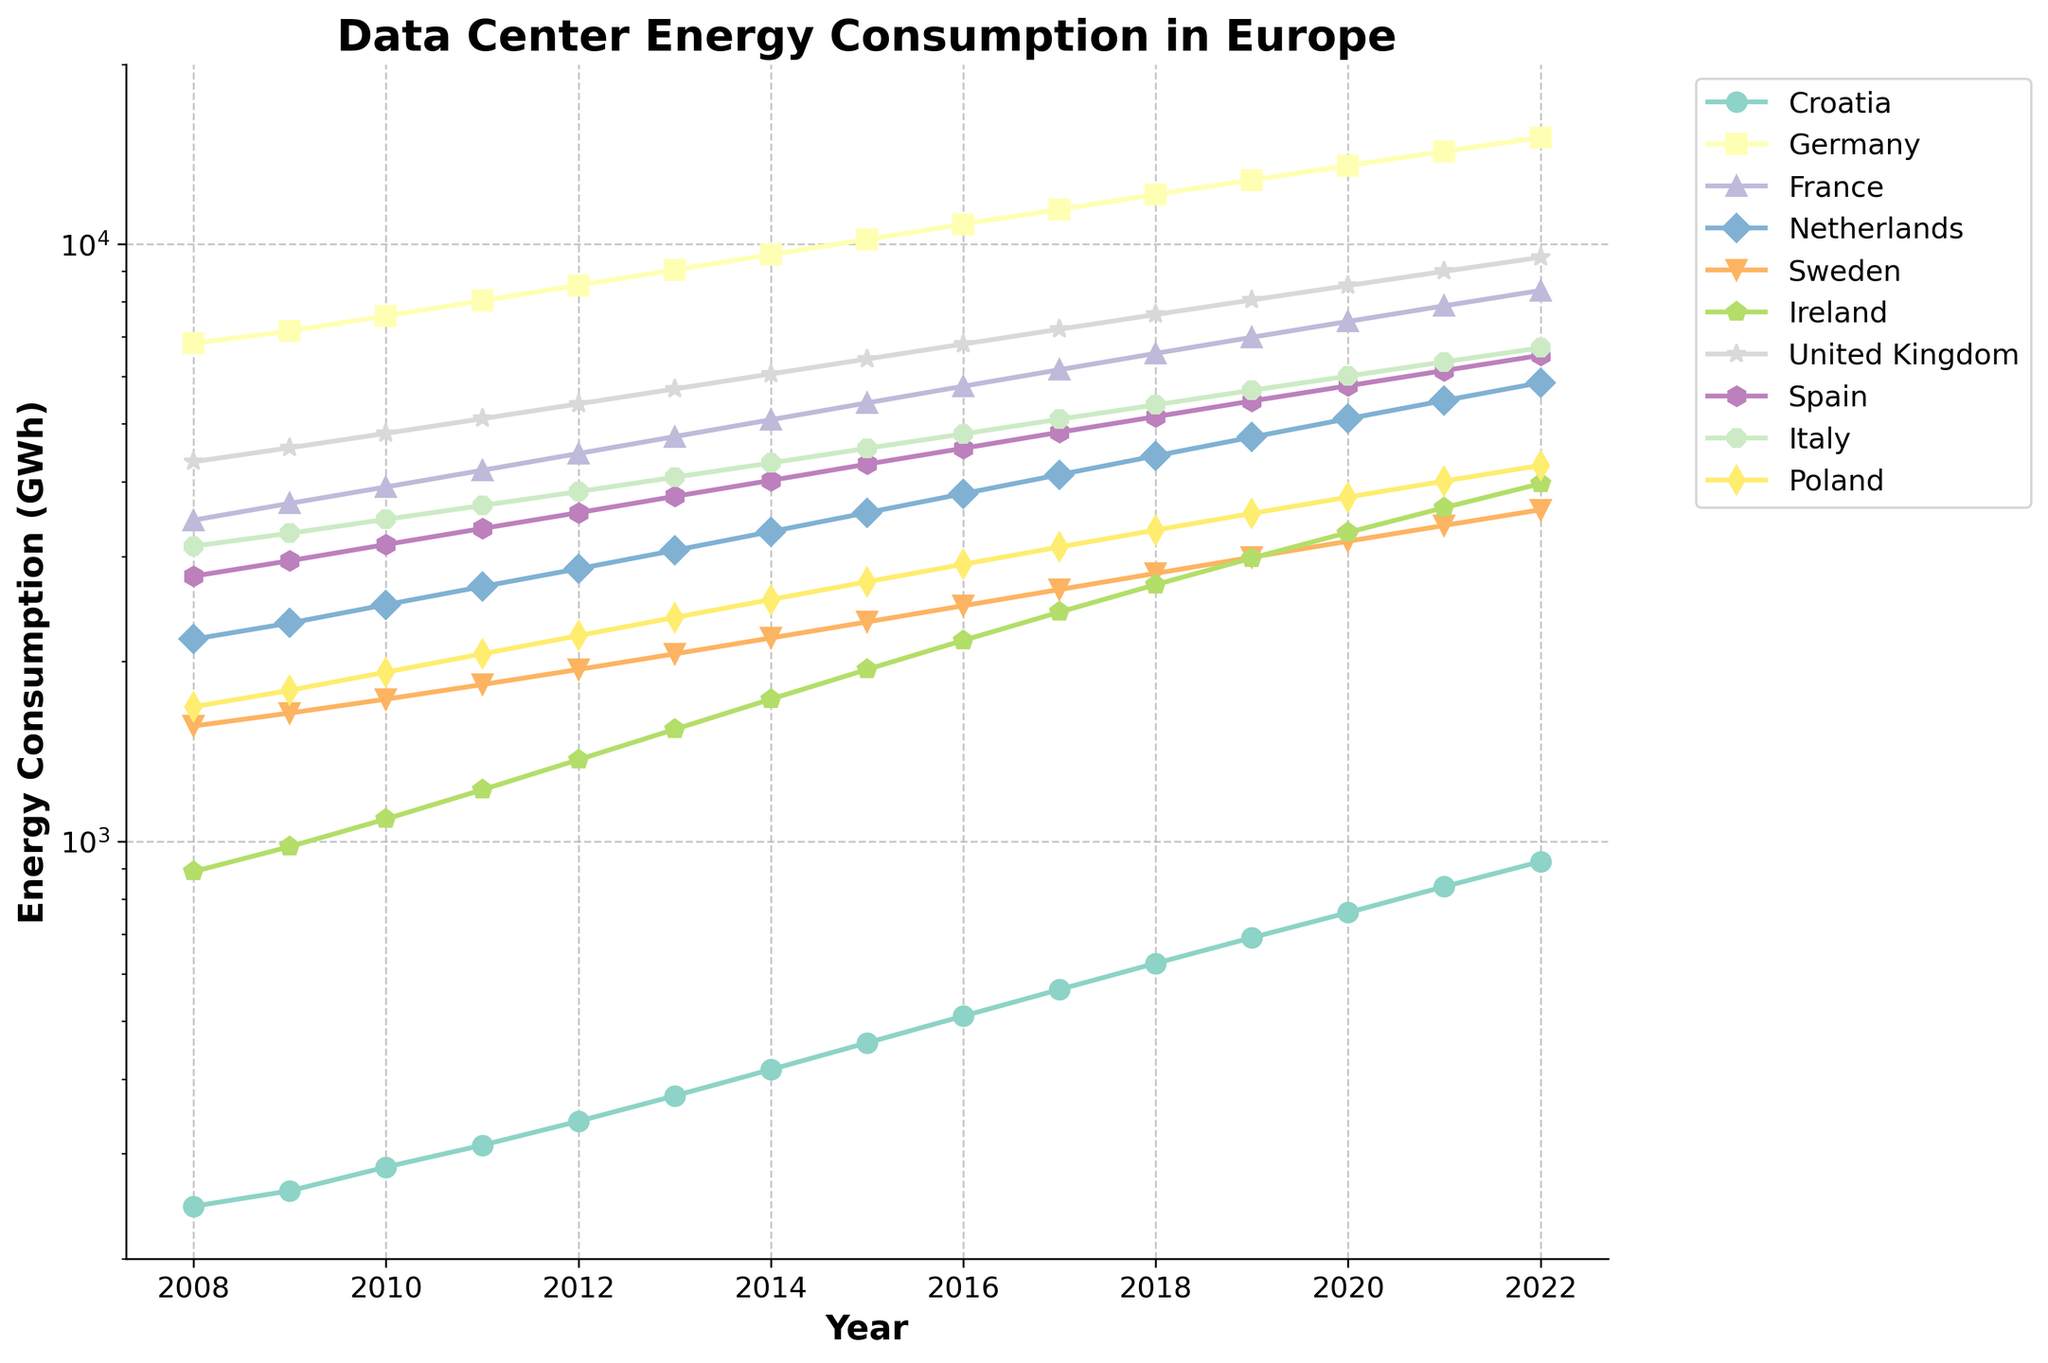What was the energy consumption in Germany in the year 2012 compared to that in Ireland? In the year 2012, Germany's energy consumption is shown in one curve, and Ireland's in another. Check the value for each country and compare them. Germany consumed 8530 GWh, while Ireland consumed 1370 GWh. Therefore, Germany's consumption was higher.
Answer: Germany's consumption was higher Which country had the lowest energy consumption in 2008, and by how much? Look at the values for all countries in 2008. The lowest value is for Croatia with 245 GWh. Other countries have values higher than that.
Answer: Croatia, 245 GWh What's the average increase in energy consumption for Sweden from 2008 to 2022? To find the increase for each year and then average them: first determine the consumption for 2008 (1560 GWh) and for 2022 (3590 GWh). The total increase is 3590 - 1560 = 2030 GWh. There are 14 intervals between 15 years, so the average increase is 2030 / 14.
Answer: 145 GWh per year By how much did the energy consumption in the Netherlands increase from 2010 to 2020? Find the value of Netherlands' consumption in 2010 (2490 GWh) and 2020 (5100 GWh). Subtract the value of 2010 from the value of 2020 (5100 - 2490).
Answer: 2610 GWh Which country's energy consumption curve shows the steepest increase around the 2015 mark? Look for the curve that shows a noticeable steep increase around 2015. Ireland's curve from 2015 to 2016 has a visible steep slope.
Answer: Ireland Compare the energy consumption growth rate of Italy and Spain from 2018 to 2021. Which country has a higher growth rate? Calculate the difference in energy consumption for Italy (6350 - 5380) and Spain (6140 - 5140) from 2018 to 2021. The growth rate for Italy is 6350 - 5380 = 970 GWh, and for Spain is 6140 - 5140 = 1000 GWh. Compare these values.
Answer: Spain What's the combined energy consumption of France and United Kingdom in 2022? Add the energy consumption values of France (8360 GWh) and United Kingdom (9500 GWh) for 2022. The sum is 8360 + 9500.
Answer: 17860 GWh Which countries have more than tripled their energy consumption from 2008 to 2022? For each country, divide the 2022 consumption by the 2008 consumption to see if the result is greater than 3. For Croatia: 925 / 245 = 3.78. For Ireland: 3970 / 890 = 4.46. These countries meet the criteria.
Answer: Croatia, Ireland Which country saw a decline in energy consumption in any year and which year was that? Check the year-to-year values for each country. Ireland shows a decline from 2018 (2690 GWh) to 2019 (2980 GWh).
Answer: Ireland, 2018 